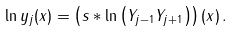<formula> <loc_0><loc_0><loc_500><loc_500>\ln y _ { j } ( x ) = \left ( s \ast \ln \left ( Y _ { j - 1 } Y _ { j + 1 } \right ) \right ) ( x ) \, .</formula> 